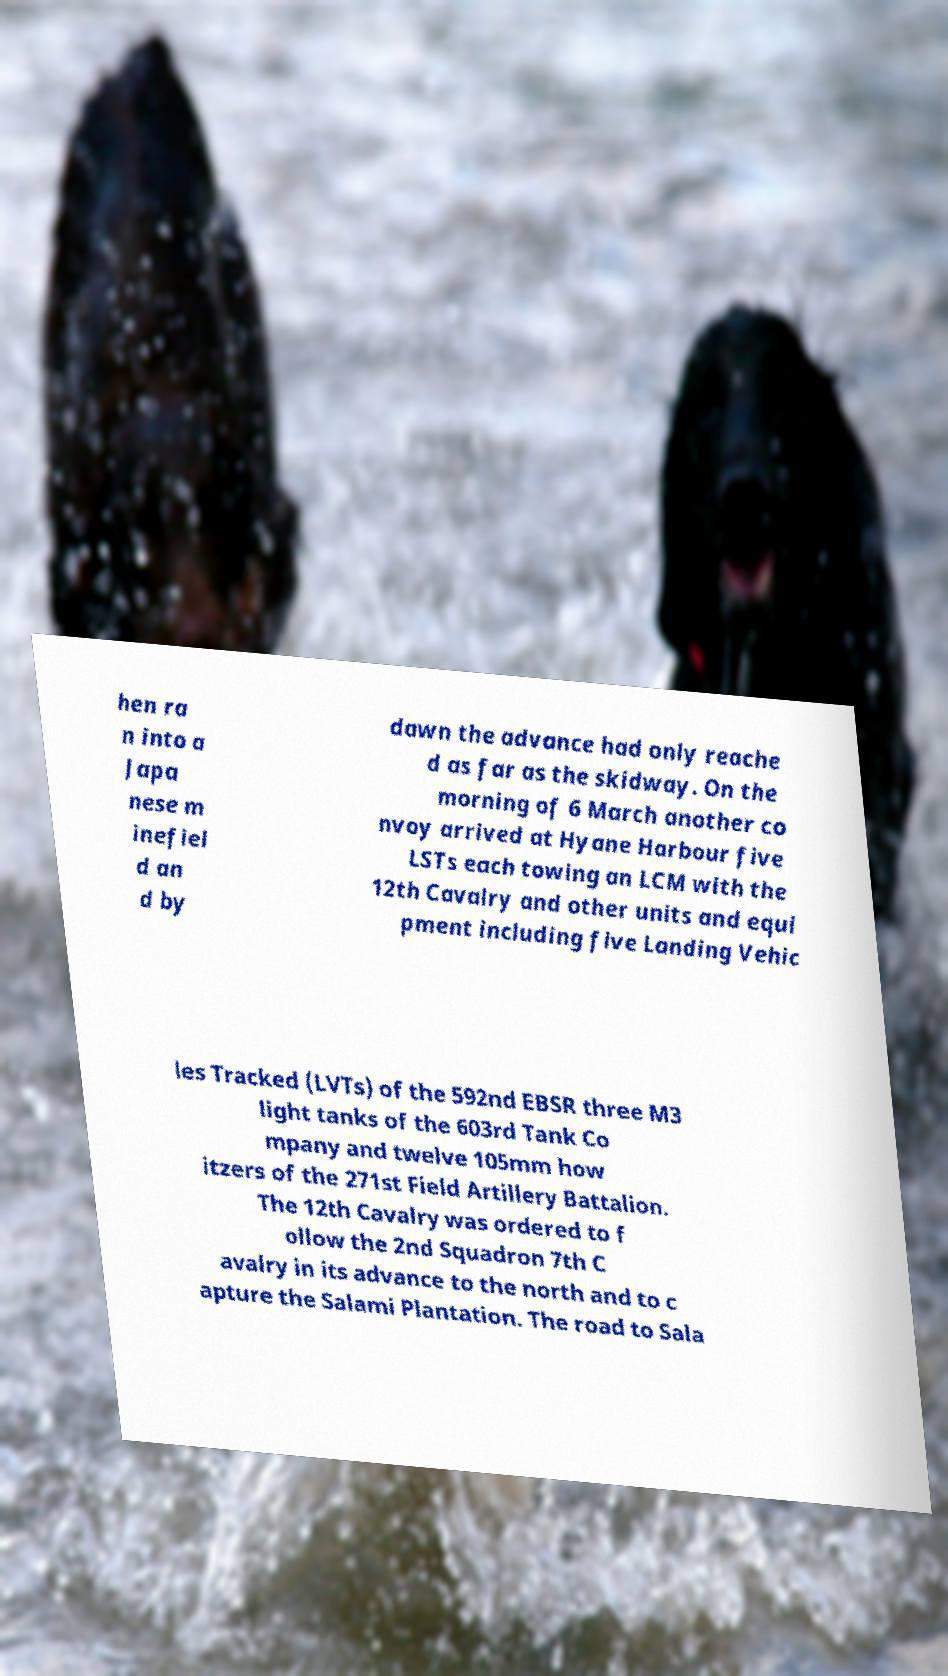Please identify and transcribe the text found in this image. hen ra n into a Japa nese m inefiel d an d by dawn the advance had only reache d as far as the skidway. On the morning of 6 March another co nvoy arrived at Hyane Harbour five LSTs each towing an LCM with the 12th Cavalry and other units and equi pment including five Landing Vehic les Tracked (LVTs) of the 592nd EBSR three M3 light tanks of the 603rd Tank Co mpany and twelve 105mm how itzers of the 271st Field Artillery Battalion. The 12th Cavalry was ordered to f ollow the 2nd Squadron 7th C avalry in its advance to the north and to c apture the Salami Plantation. The road to Sala 